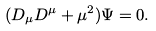<formula> <loc_0><loc_0><loc_500><loc_500>( D _ { \mu } D ^ { \mu } + \mu ^ { 2 } ) \Psi = 0 .</formula> 